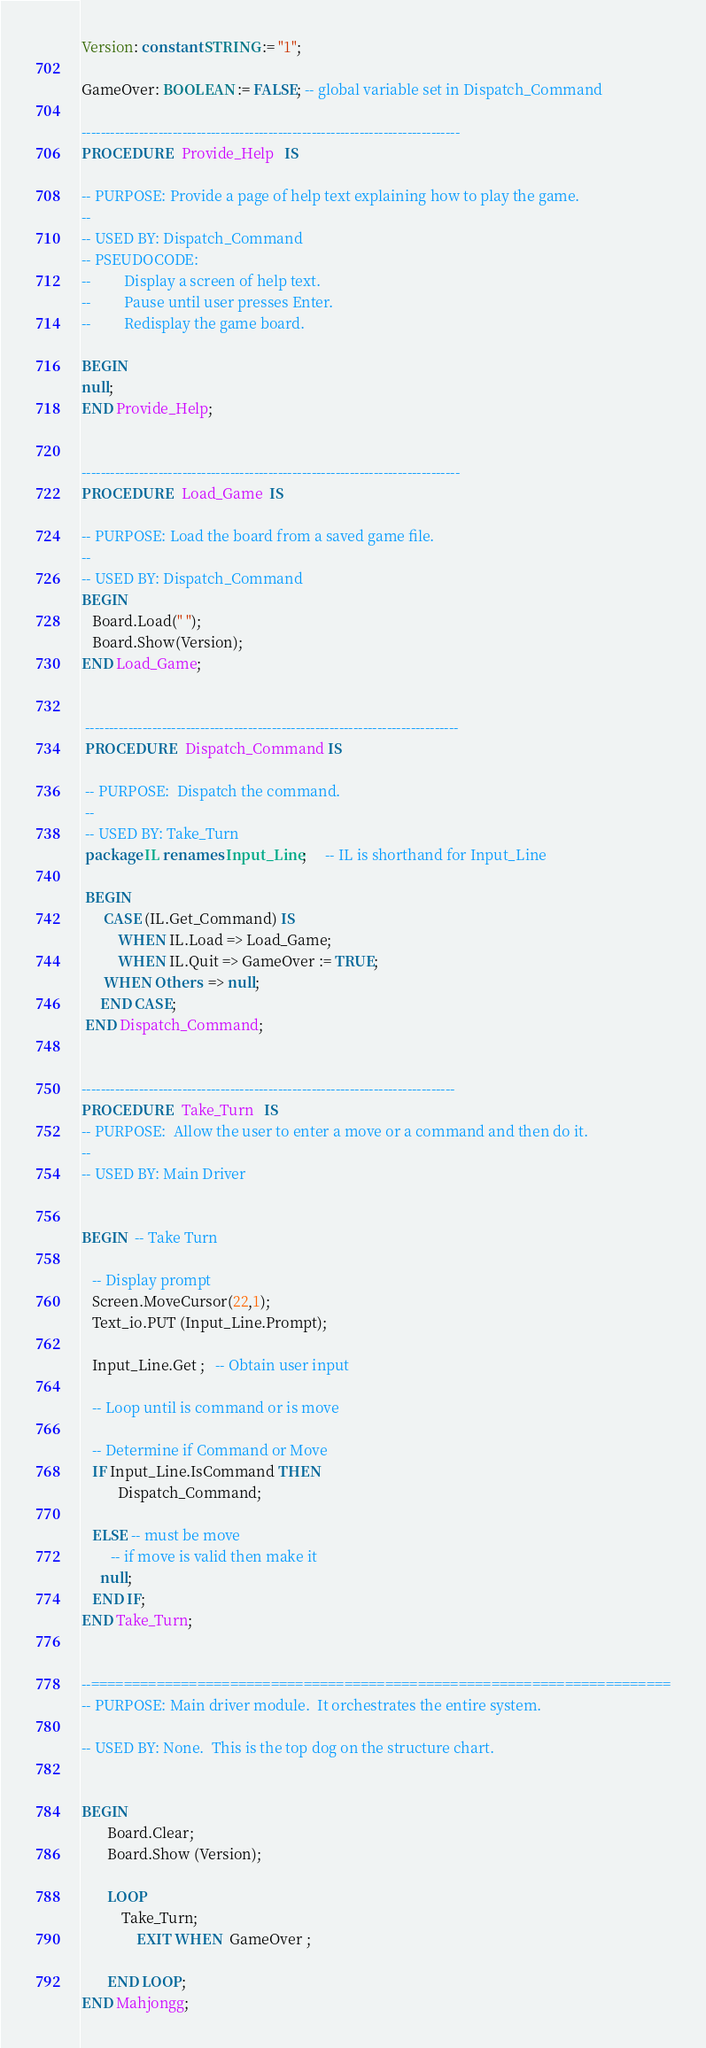Convert code to text. <code><loc_0><loc_0><loc_500><loc_500><_Ada_>Version: constant STRING := "1";

GameOver: BOOLEAN := FALSE; -- global variable set in Dispatch_Command

-------------------------------------------------------------------------------
PROCEDURE   Provide_Help   IS

-- PURPOSE: Provide a page of help text explaining how to play the game.
--
-- USED BY: Dispatch_Command
-- PSEUDOCODE:
--         Display a screen of help text.
--         Pause until user presses Enter.
--         Redisplay the game board.

BEGIN
null;
END Provide_Help;


-------------------------------------------------------------------------------
PROCEDURE   Load_Game  IS

-- PURPOSE: Load the board from a saved game file.
--
-- USED BY: Dispatch_Command
BEGIN
   Board.Load(" ");  
   Board.Show(Version);
END Load_Game;


 ------------------------------------------------------------------------------
 PROCEDURE   Dispatch_Command IS

 -- PURPOSE:  Dispatch the command.
 --
 -- USED BY: Take_Turn
 package IL renames Input_Line;     -- IL is shorthand for Input_Line

 BEGIN
      CASE (IL.Get_Command) IS
          WHEN IL.Load => Load_Game;
          WHEN IL.Quit => GameOver := TRUE;
	  WHEN Others  => null;
     END CASE;
 END Dispatch_Command;


------------------------------------------------------------------------------
PROCEDURE   Take_Turn   IS
-- PURPOSE:  Allow the user to enter a move or a command and then do it.
--
-- USED BY: Main Driver 


BEGIN  -- Take Turn

   -- Display prompt
   Screen.MoveCursor(22,1);
   Text_io.PUT (Input_Line.Prompt);

   Input_Line.Get ;   -- Obtain user input

   -- Loop until is command or is move

   -- Determine if Command or Move
   IF Input_Line.IsCommand THEN
          Dispatch_Command;
          
   ELSE -- must be move
		-- if move is valid then make it
     null;
   END IF;
END Take_Turn;


--=======================================================================
-- PURPOSE: Main driver module.  It orchestrates the entire system.

-- USED BY: None.  This is the top dog on the structure chart.


BEGIN
       Board.Clear;
       Board.Show (Version);

       LOOP
	       Take_Turn;
               EXIT WHEN  GameOver ;
               
       END LOOP;
END Mahjongg;

</code> 